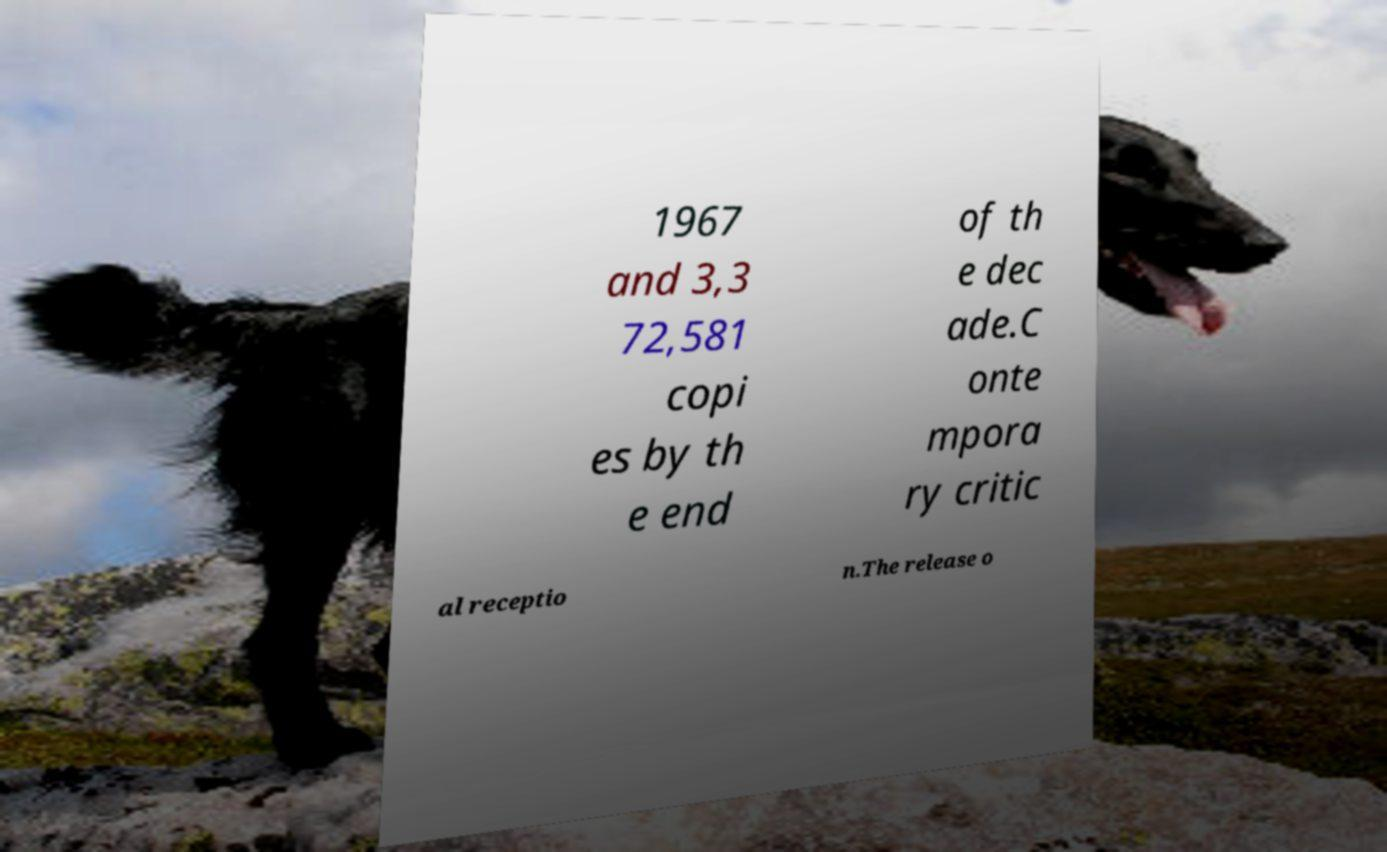Can you accurately transcribe the text from the provided image for me? 1967 and 3,3 72,581 copi es by th e end of th e dec ade.C onte mpora ry critic al receptio n.The release o 